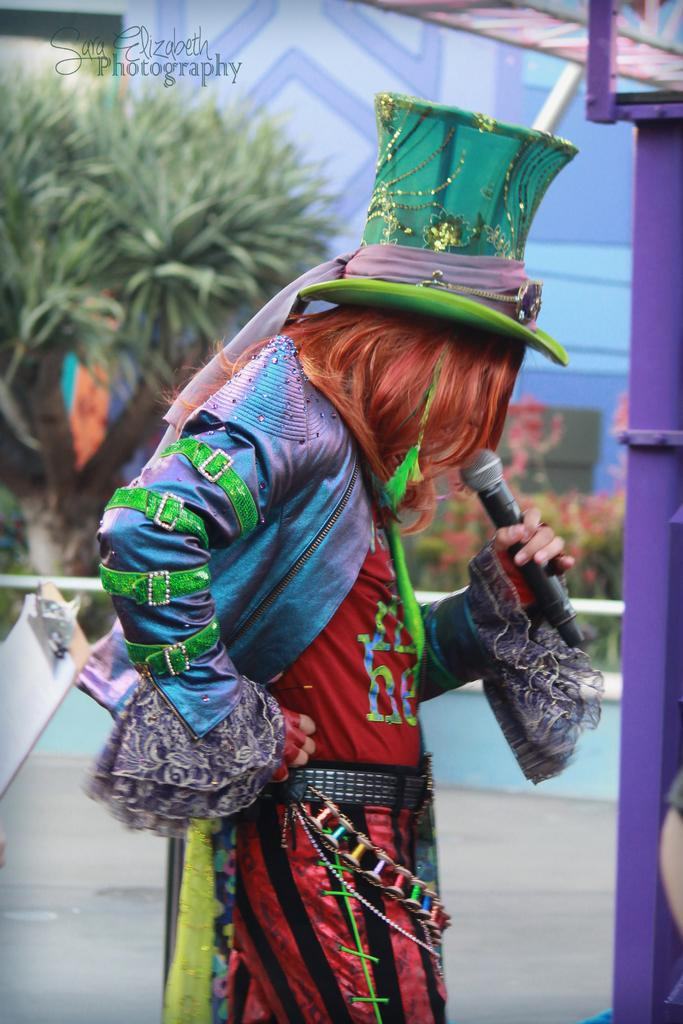Who is the main subject in the image? There is a person in the center of the image. What is the person wearing? The person is wearing a cap. What is the person holding? The person is holding a mic. What can be seen in the background of the image? There is a wall and a tree in the background of the image. What type of crime is being committed in the image? There is no indication of any crime being committed in the image. How many trees are visible in the image? The facts provided only mention one tree visible in the background of the image. 